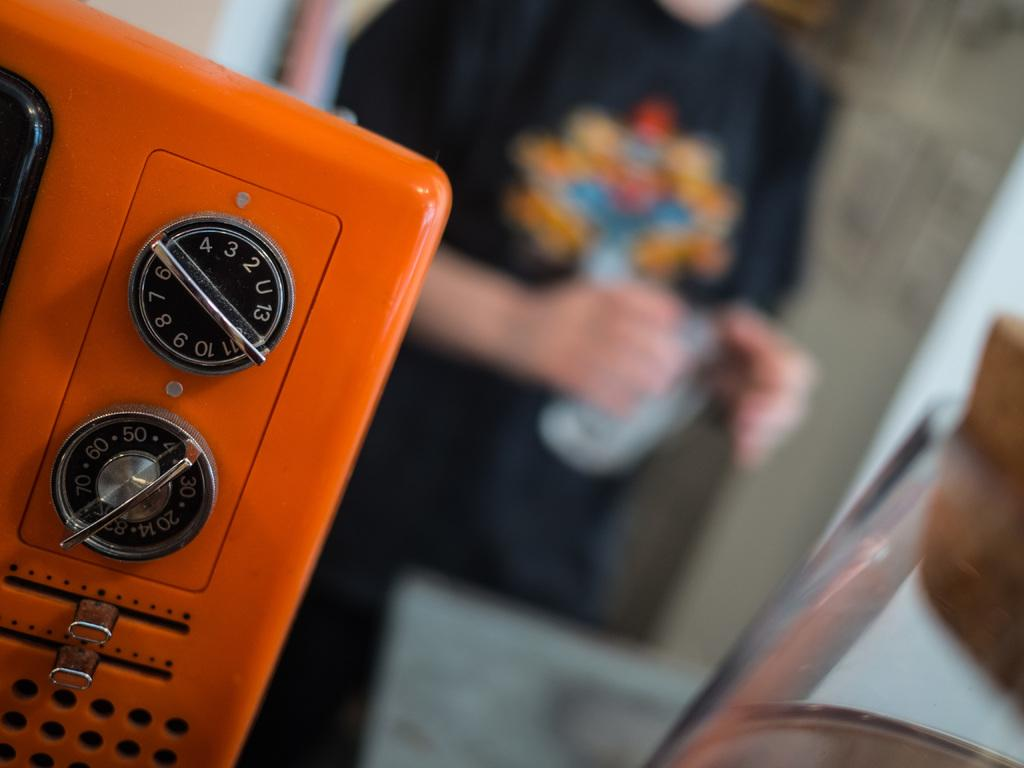What type of electronic device is visible in the image? There is an electronic device with knobs in the image. Can you describe the background of the image? The background of the image is blurred. Is there anyone present in the image? Yes, there is a person standing in the image. What type of wine is the person holding in the image? There is no wine present in the image; the person is not holding anything. 